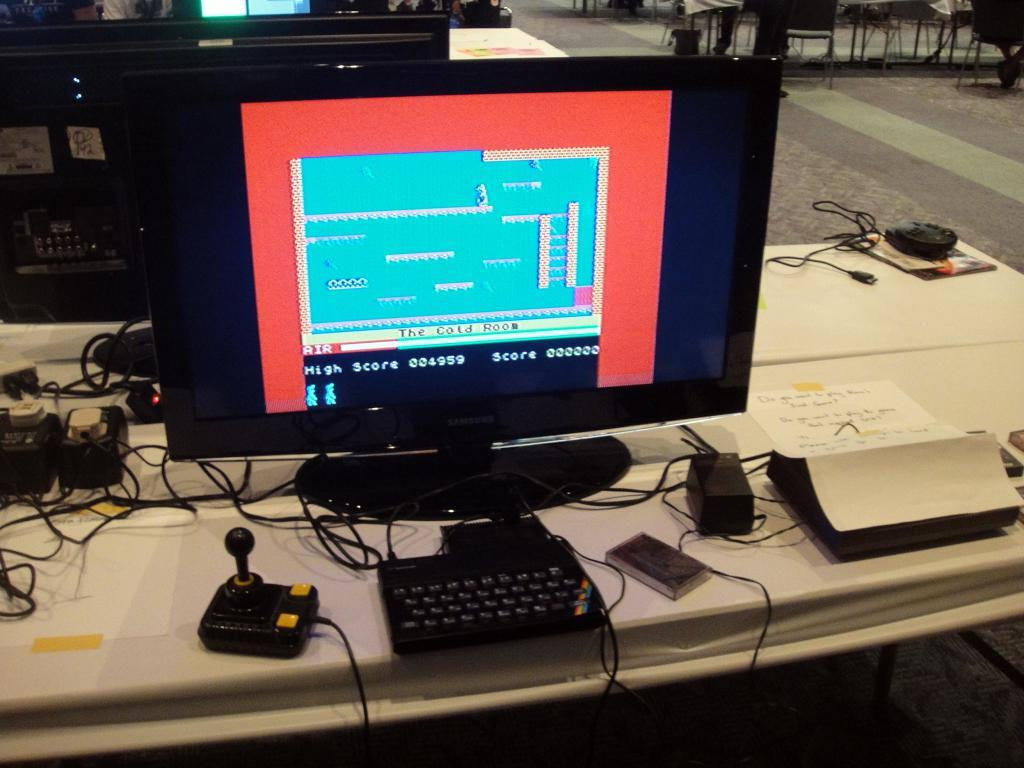<image>
Share a concise interpretation of the image provided. Computer screen that is showing the high score of a video game. 